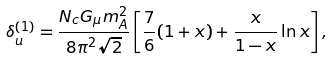<formula> <loc_0><loc_0><loc_500><loc_500>\delta _ { u } ^ { ( 1 ) } = \frac { N _ { c } G _ { \mu } m _ { A } ^ { 2 } } { 8 \pi ^ { 2 } \sqrt { 2 } } \left [ \frac { 7 } { 6 } ( 1 + x ) + \frac { x } { 1 - x } \ln x \right ] ,</formula> 